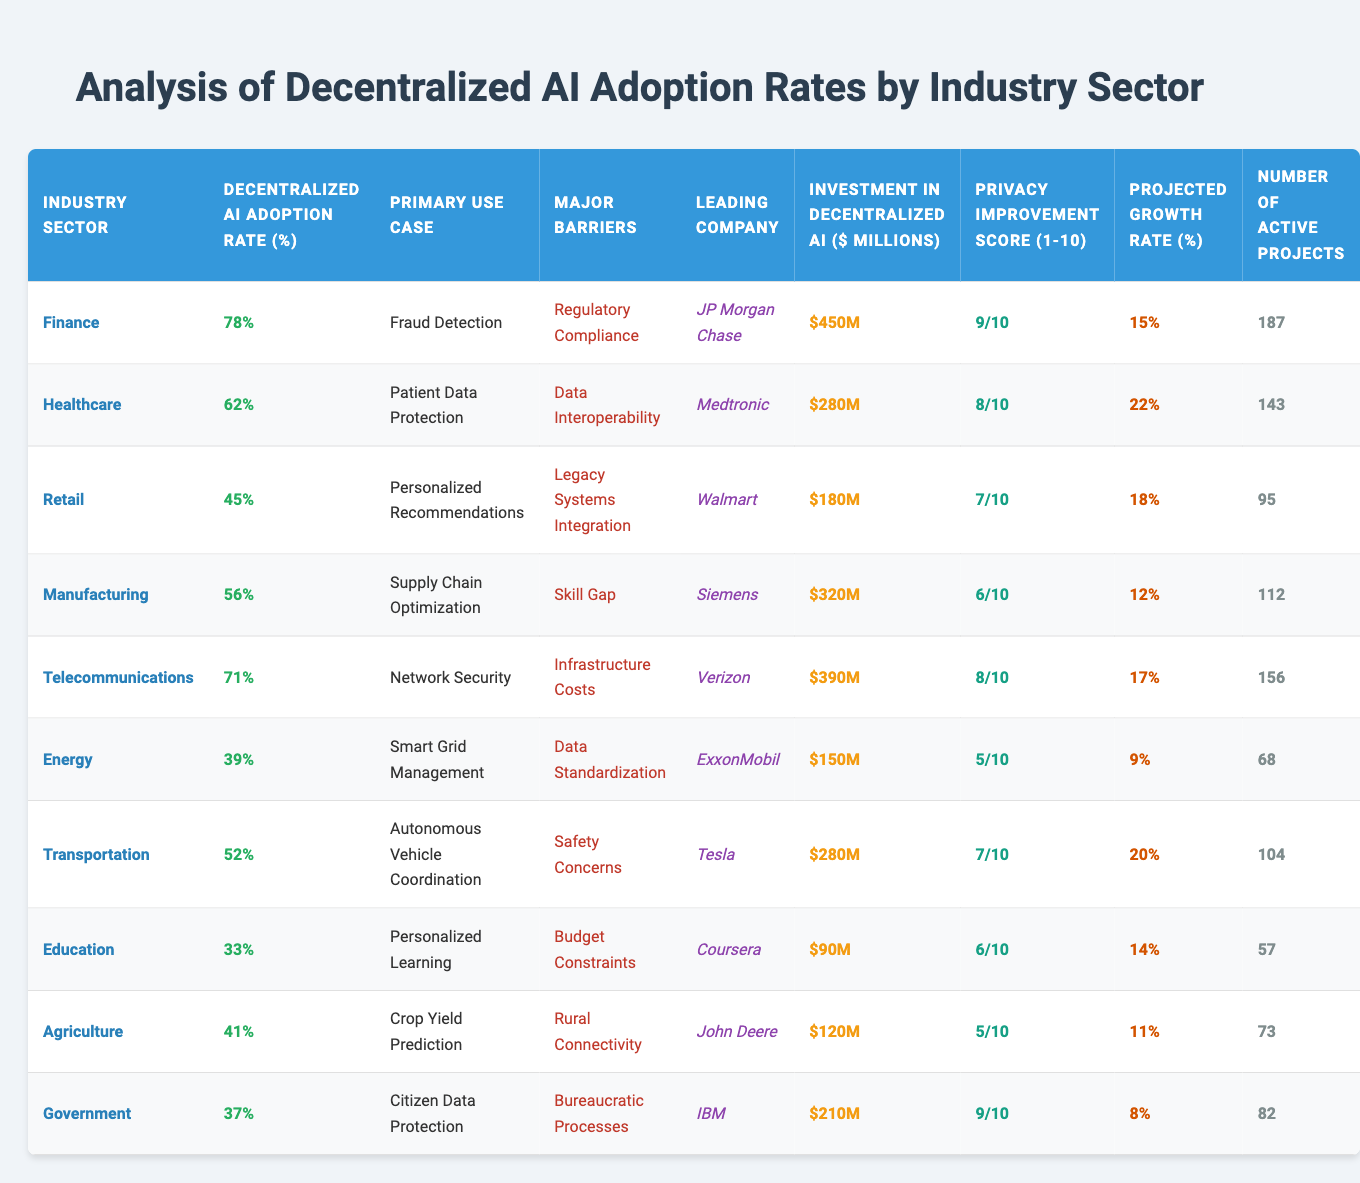What is the decentralized AI adoption rate in the Finance sector? The Finance sector has a decentralized AI adoption rate of 78%, as indicated in the table under the "Decentralized AI Adoption Rate (%)" column.
Answer: 78% Which industry sector has the highest investment in decentralized AI? The industry sector with the highest investment in decentralized AI is Finance, with an investment of $450 million, as seen in the "Investment in Decentralized AI ($ millions)" column.
Answer: Finance What is the projected growth rate for the Healthcare sector? The projected growth rate for the Healthcare sector is 22%, which can be found in the "Projected Growth Rate (%)" column corresponding to Healthcare.
Answer: 22% True or False: The Telecommunications sector has more active projects than the Agriculture sector. The Telecommunications sector has 156 active projects while the Agriculture sector has 73. Since 156 is greater than 73, the statement is true.
Answer: True What is the difference in decentralized AI adoption rates between the Retail and Government sectors? The Retail sector has an adoption rate of 45%, while the Government sector has a rate of 37%. The difference is calculated by subtracting the Government's rate from Retail's rate: 45 - 37 = 8.
Answer: 8% Which sector has a higher Privacy Improvement Score: Agriculture or Transportation? The Agriculture sector has a Privacy Improvement Score of 5, and the Transportation sector has a score of 7. Since 7 is greater than 5, Transportation has a higher score.
Answer: Transportation What is the average investment in decentralized AI across all sectors? The total investment across all sectors is $450 + $280 + $180 + $320 + $390 + $150 + $280 + $90 + $120 + $210 = $2270 million. Since there are 10 sectors, the average is $2270 / 10 = $227 million.
Answer: $227 million Which sector has the lowest decentralized AI adoption rate and what is that rate? The sector with the lowest decentralized AI adoption rate is Education at 33%, as indicated in the "Decentralized AI Adoption Rate (%)" column.
Answer: 33% Which leading company in the Manufacturing sector has the highest Privacy Improvement Score? In the Manufacturing sector, Siemens is the leading company, and it has a Privacy Improvement Score of 6, which is higher than the corresponding scores of other sectors.
Answer: Siemens Calculate the sum of active projects in Finance and Healthcare. The Finance sector has 187 active projects, and Healthcare has 143. The sum is calculated as 187 + 143 = 330.
Answer: 330 